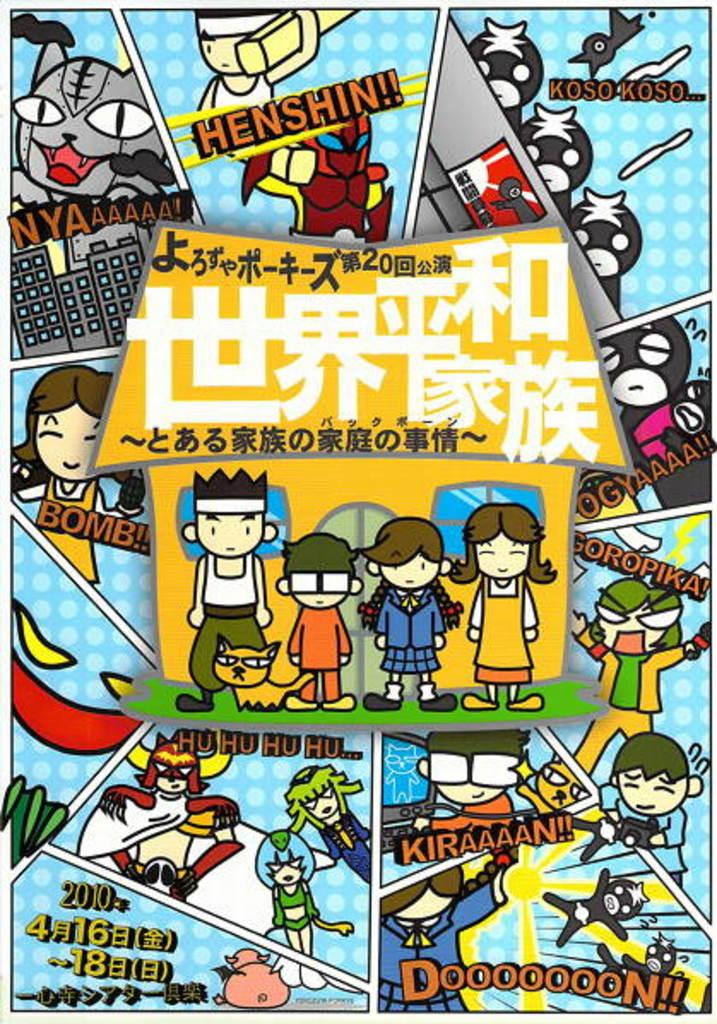<image>
Relay a brief, clear account of the picture shown. A Japanese comic strip with the word Dooooooon at the bottom. 